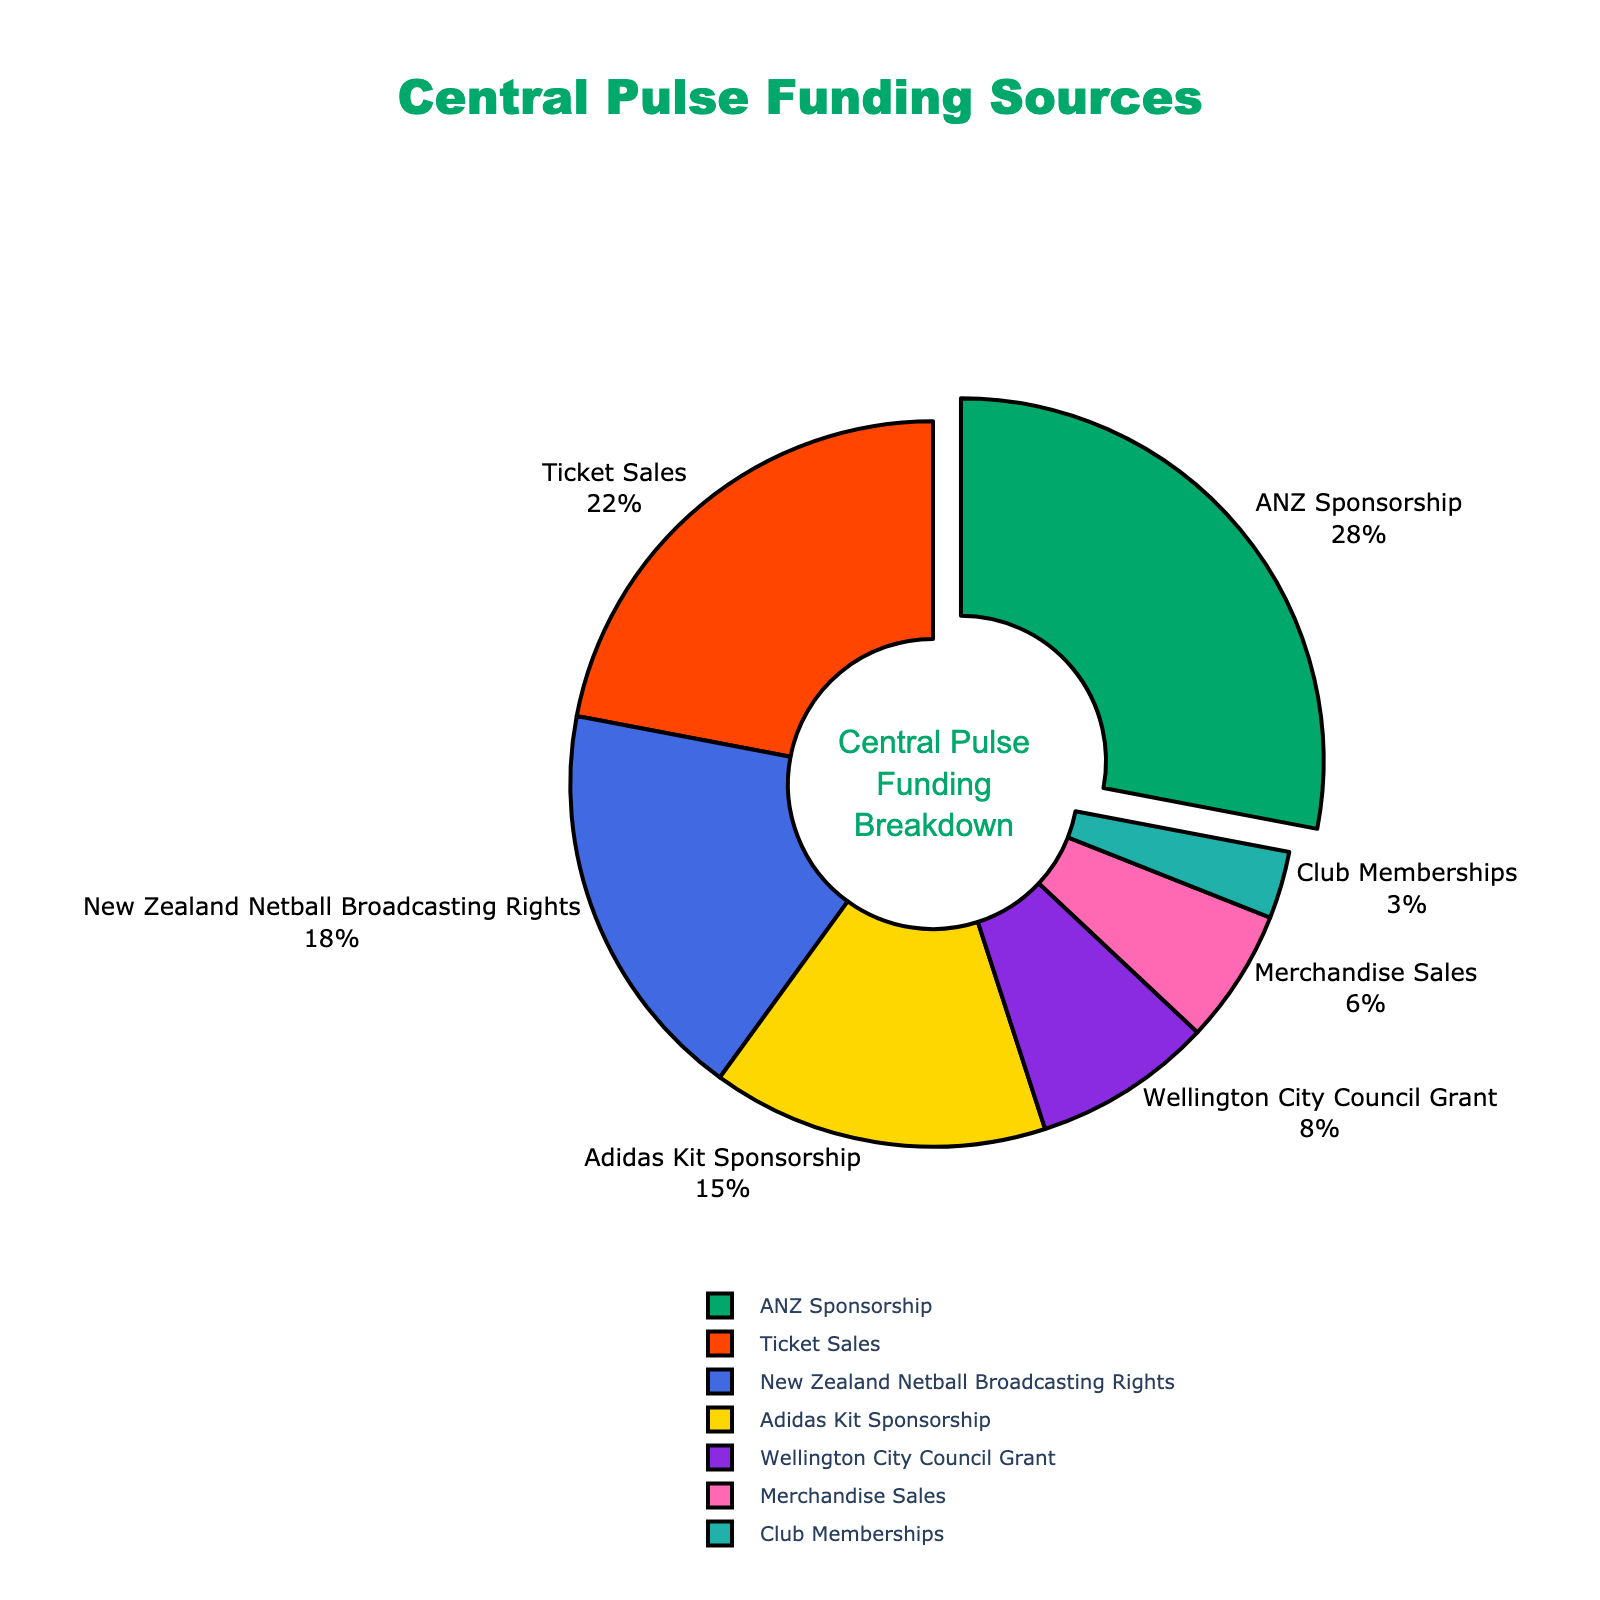What funding source contributes the most to Central Pulse's funding? The largest segment in the pie chart is annotated with 28%, which belongs to ANZ Sponsorship. Therefore, ANZ Sponsorship is the biggest contributor.
Answer: ANZ Sponsorship How much more does the ANZ Sponsorship contribute compared to the Wellington City Council Grant? The ANZ Sponsorship contributes 28%, and the Wellington City Council Grant contributes 8%. The difference between them is 28% - 8% = 20%.
Answer: 20% What is the total percentage contribution of Adidas Kit Sponsorship and Merchandise Sales? Adidas Kit Sponsorship contributes 15%, and Merchandise Sales contributes 6%. Their combined contribution is 15% + 6% = 21%.
Answer: 21% Which funding source is represented by the smallest segment in the pie chart? The smallest segment is 3%, which is attributed to Club Memberships as per the figure's legend.
Answer: Club Memberships Are Ticket Sales a greater or lesser contribution compared to New Zealand Netball Broadcasting Rights? Ticket Sales contribute 22%, whereas New Zealand Netball Broadcasting Rights contribute 18%. Since 22% is greater than 18%, Ticket Sales contribute more.
Answer: Greater Looking at the color distribution, which segment is represented in green? The green segment is visually the first one and represents ANZ Sponsorship at 28%, as indicated by the legend.
Answer: ANZ Sponsorship What percentage of Central Pulse's funding comes from government-related sources? The only government-related source is the Wellington City Council Grant, which contributes 8%.
Answer: 8% Compare the combined contribution of sponsorships (ANZ and Adidas Kit) to Ticket Sales. Which is higher and by how much? ANZ Sponsorship is 28%, and Adidas Kit Sponsorship is 15%. Their combined contribution is 28% + 15% = 43%. Ticket Sales contribute 22%. The difference is 43% - 22% = 21%. So sponsorships contribute 21% more.
Answer: Sponsorships, 21% Which funding categories contribute more than 15% individually? ANZ Sponsorship (28%), Ticket Sales (22%), and New Zealand Netball Broadcasting Rights (18%) individually contribute more than 15% as indicated on the pie chart.
Answer: ANZ Sponsorship, Ticket Sales, New Zealand Netball Broadcasting Rights By looking at both the percentage and color, identify which segment is represented in purple. The purple segment (identified by its color) is marked as 8%, which, according to the legend, represents the Wellington City Council Grant.
Answer: Wellington City Council Grant 